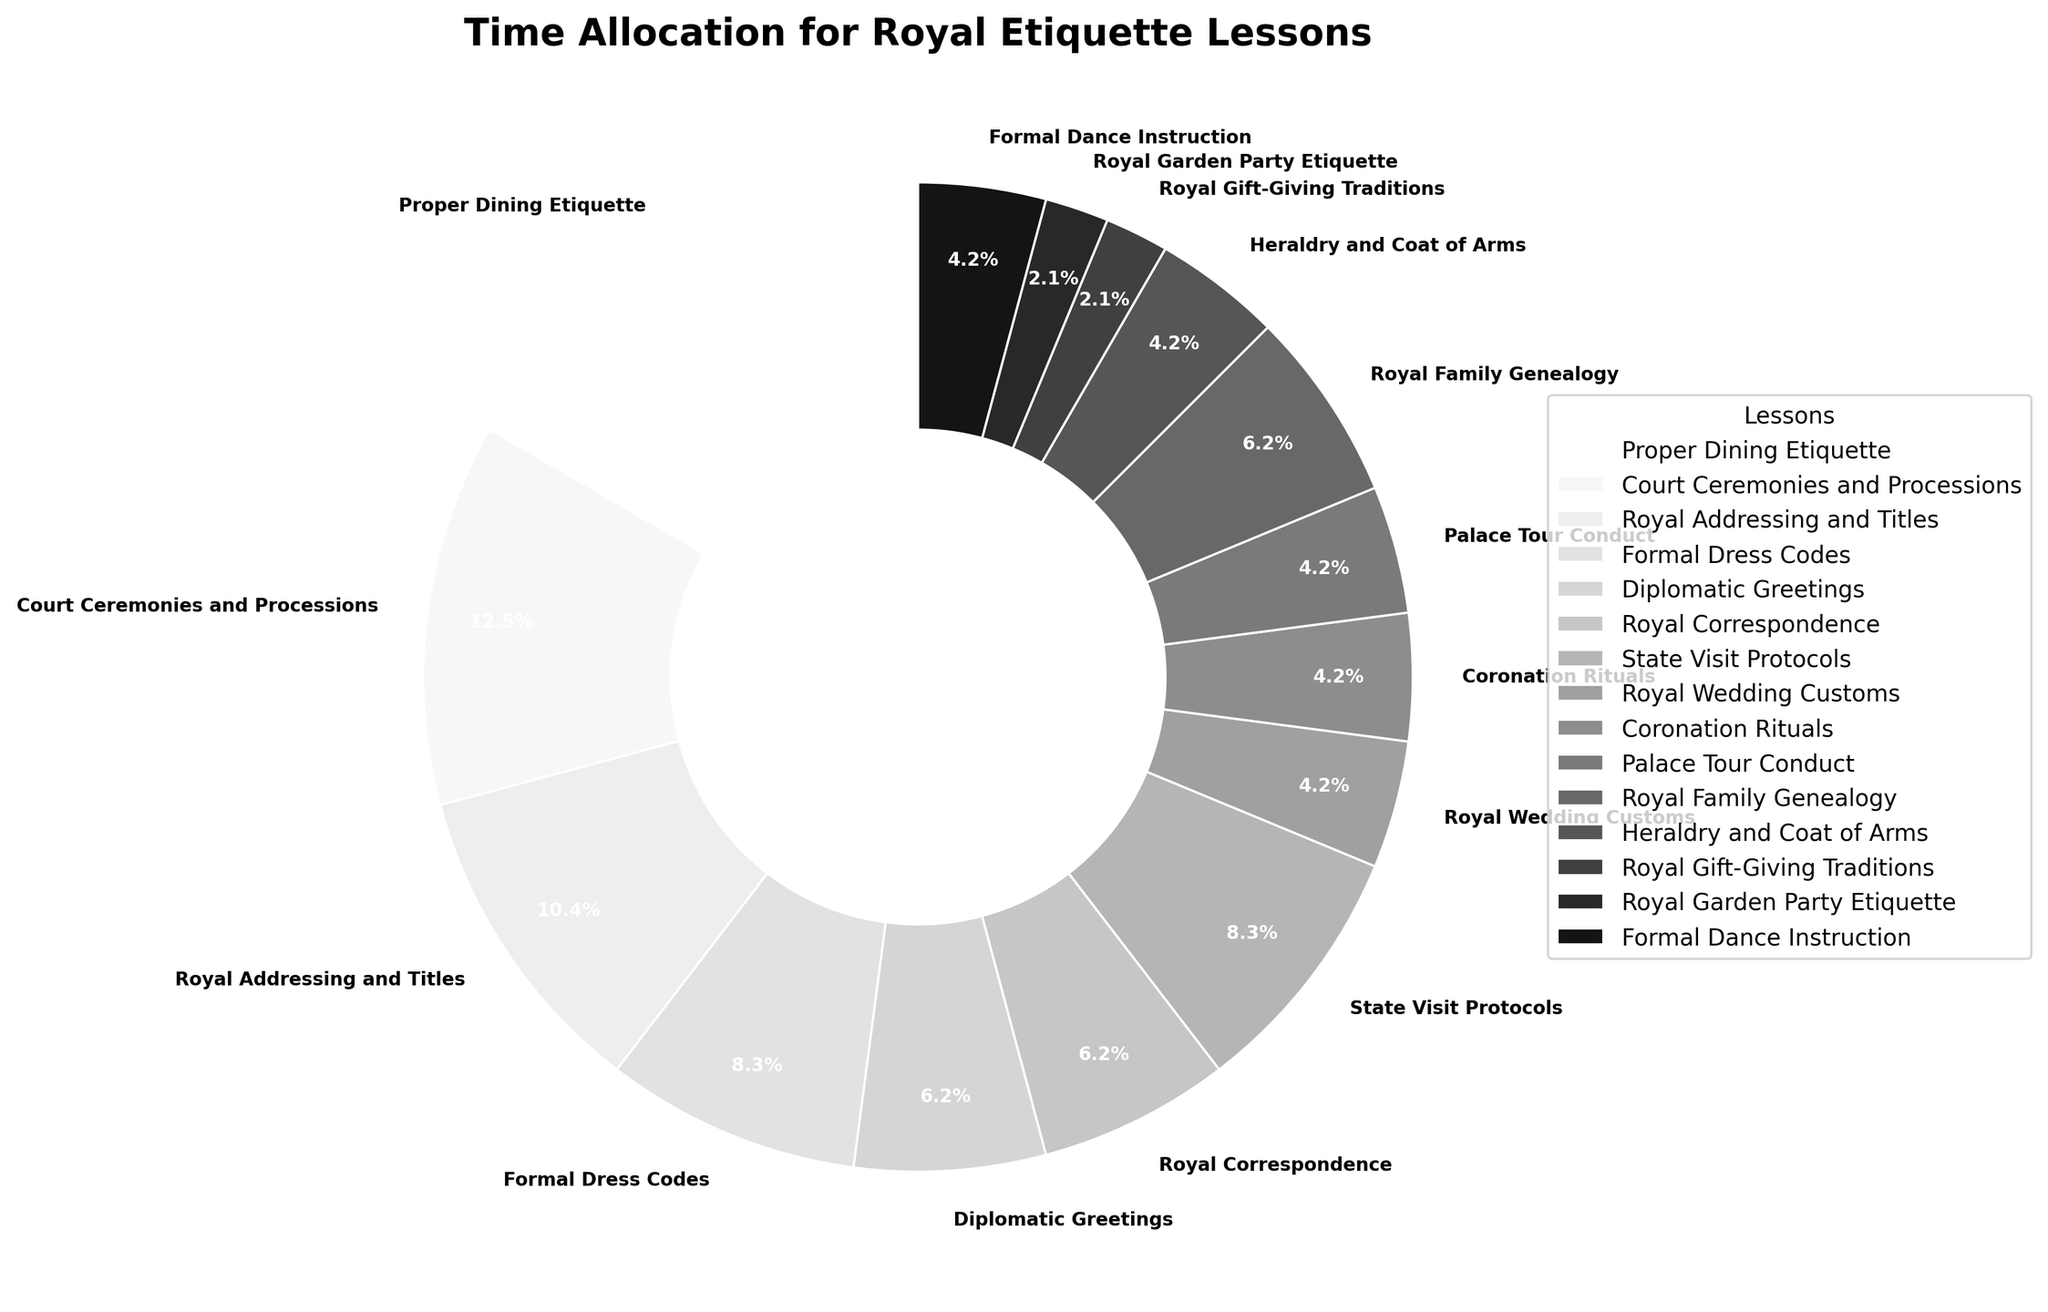What is the most time-consuming lesson? The lesson with the largest segment of the pie chart is "Proper Dining Etiquette," which occupies the biggest area visually.
Answer: Proper Dining Etiquette How many hours are allocated to Royal Wedding Customs and Coronation Rituals combined? Royal Wedding Customs and Coronation Rituals each have a small segment, with both labeled as 2 hours each. Adding these gives 2 + 2 = 4 hours.
Answer: 4 hours Which lesson takes more time: Diplomatic Greetings or Royal Correspondence? Comparing the segments of Diplomatic Greetings and Royal Correspondence, we see that both have the same size and are labeled as 3 hours each.
Answer: They take equal time How much more time is spent on Proper Dining Etiquette than on Royal Family Genealogy? Proper Dining Etiquette accounts for 8 hours, and Royal Family Genealogy accounts for 3 hours. The difference is 8 - 3 = 5 hours.
Answer: 5 hours What percentage of the total time is allocated to Court Ceremonies and Processions? Observing the pie chart, the segment labeled Court Ceremonies and Processions shows 6 hours. To find the percentage, calculate (6 hours / total hours) * 100. The total hours sum up to 46 hours. Therefore, (6/46) * 100 ≈ 13%.
Answer: 13% Are there more hours allocated to Formal Dance Instruction or to Heraldry and Coat of Arms? By comparing the two segments representing these lessons, Formal Dance Instruction has 2 hours, and Heraldry and Coat of Arms has 2 hours. They are equal.
Answer: They are the same Which lessons have the same number of hours allocated to them? Observing the pie chart, the lessons with the same number of hours are Royal Wedding Customs, Coronation Rituals, Palace Tour Conduct, Heraldry and Coat of Arms, and Formal Dance Instruction, as each has 2 hours. Other pairs are Diplomatic Greetings, Royal Correspondence, and Royal Family Genealogy, each with 3 hours.
Answer: Multiple pairs (2 hours each: Royal Wedding Customs, Coronation Rituals, Palace Tour Conduct, Heraldry and Coat of Arms, Formal Dance Instruction; 3 hours each: Diplomatic Greetings, Royal Correspondence, Royal Family Genealogy) Which lesson takes the smallest portion of the chart and how many hours is it allocated? The smallest segments of the pie chart are Royal Gift-Giving Traditions and Royal Garden Party Etiquette, each allocated 1 hour.
Answer: Royal Gift-Giving Traditions and Royal Garden Party Etiquette (1 hour each) How many lessons are allocated exactly 2 hours each? Counting the segments labeled 2 hours, we find Royal Wedding Customs, Coronation Rituals, Palace Tour Conduct, Heraldry and Coat of Arms, and Formal Dance Instruction. This gives us 5 lessons.
Answer: 5 lessons What is the total time spent on lessons related to state or diplomatic interactions? Summing up hours for lessons related to diplomatic interactions - Diplomatic Greetings (3 hours), State Visit Protocols (4 hours), and Royal Correspondence (3 hours) - we get 3 + 4 + 3 = 10 hours.
Answer: 10 hours 